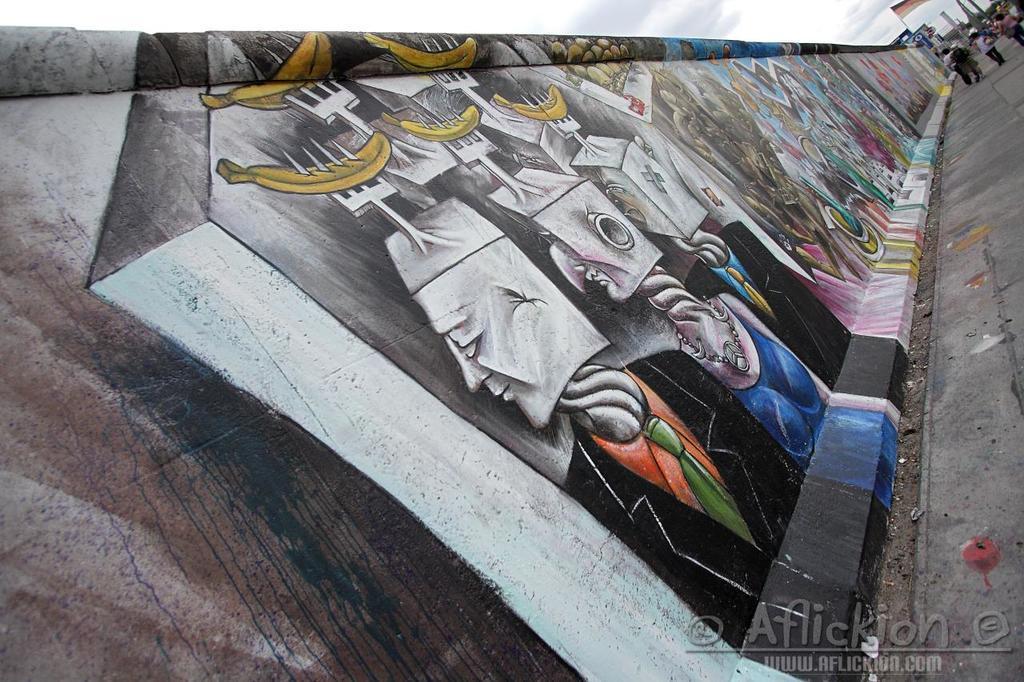Please provide a concise description of this image. We can see painting on the wall. In the background we can see people, poles and sky. In the bottom right side of the image we can see watermark. 